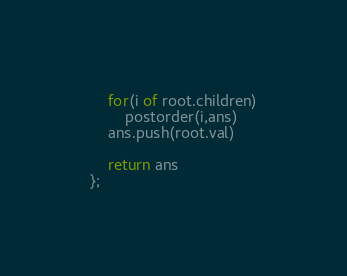Convert code to text. <code><loc_0><loc_0><loc_500><loc_500><_JavaScript_>    for(i of root.children)
        postorder(i,ans)
    ans.push(root.val)
    
    return ans
};</code> 